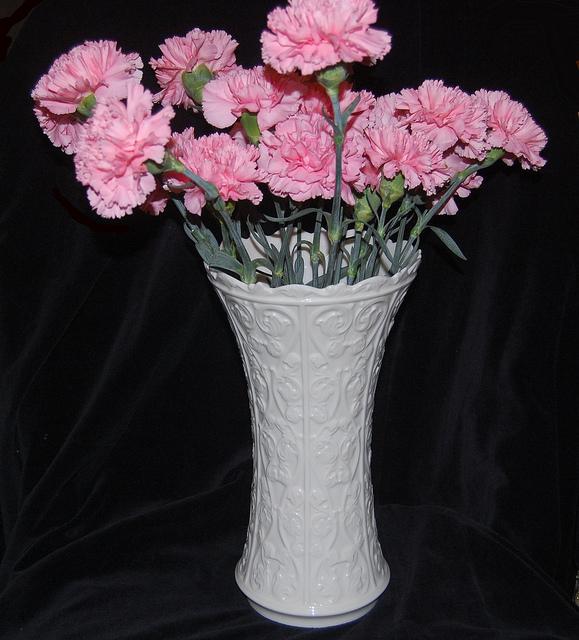Where are the flowers?
Answer briefly. Vase. What type of flowers are in the vase?
Give a very brief answer. Carnations. What color is the vase?
Be succinct. White. Would a typical human consume these flowers on a salad?
Write a very short answer. No. 